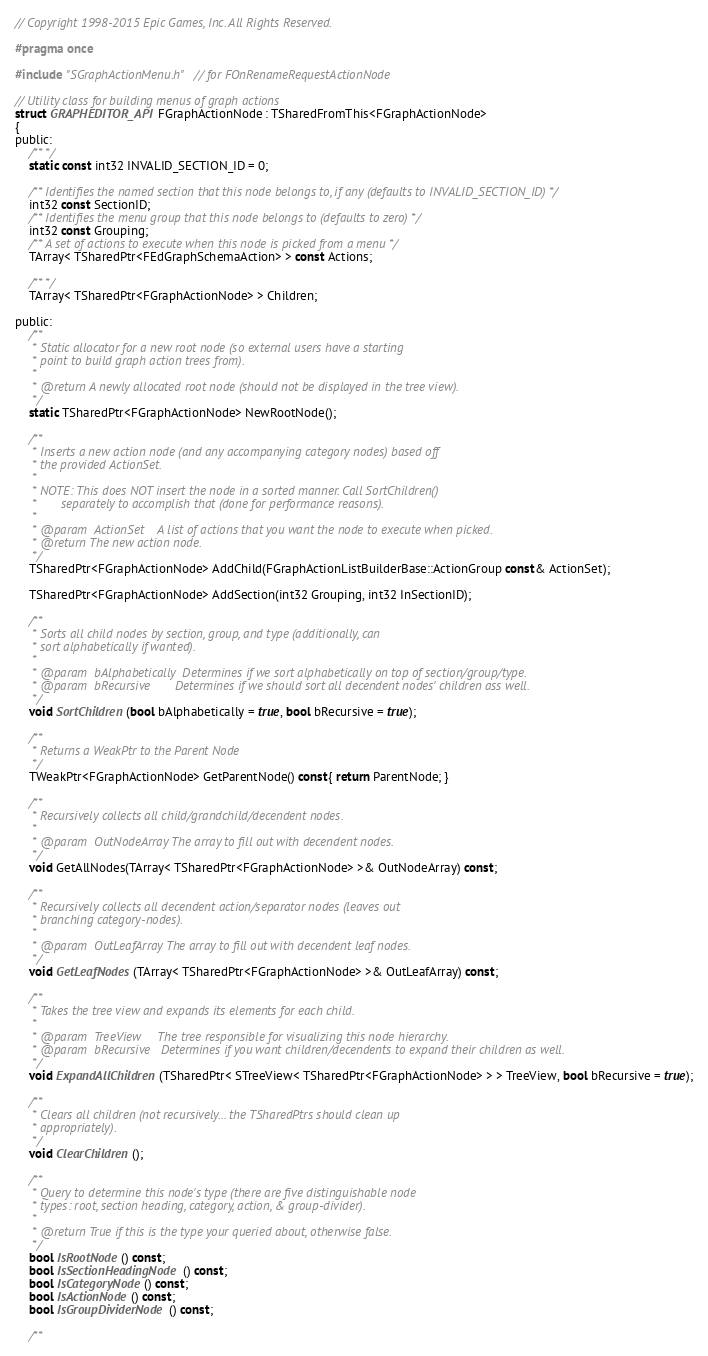Convert code to text. <code><loc_0><loc_0><loc_500><loc_500><_C_>// Copyright 1998-2015 Epic Games, Inc. All Rights Reserved.

#pragma once

#include "SGraphActionMenu.h" // for FOnRenameRequestActionNode

// Utility class for building menus of graph actions
struct GRAPHEDITOR_API FGraphActionNode : TSharedFromThis<FGraphActionNode>
{
public:
	/** */
	static const int32 INVALID_SECTION_ID = 0;

	/** Identifies the named section that this node belongs to, if any (defaults to INVALID_SECTION_ID) */
	int32 const SectionID;
	/** Identifies the menu group that this node belongs to (defaults to zero) */
	int32 const Grouping;
	/** A set of actions to execute when this node is picked from a menu */
	TArray< TSharedPtr<FEdGraphSchemaAction> > const Actions;

	/** */
	TArray< TSharedPtr<FGraphActionNode> > Children;

public:
	/**
	 * Static allocator for a new root node (so external users have a starting
	 * point to build graph action trees from).
	 *
	 * @return A newly allocated root node (should not be displayed in the tree view).
	 */
	static TSharedPtr<FGraphActionNode> NewRootNode();

	/**
	 * Inserts a new action node (and any accompanying category nodes) based off
	 * the provided ActionSet. 
	 *
	 * NOTE: This does NOT insert the node in a sorted manner. Call SortChildren() 
	 *       separately to accomplish that (done for performance reasons).
	 * 
	 * @param  ActionSet	A list of actions that you want the node to execute when picked.
	 * @return The new action node.
	 */
	TSharedPtr<FGraphActionNode> AddChild(FGraphActionListBuilderBase::ActionGroup const& ActionSet);

	TSharedPtr<FGraphActionNode> AddSection(int32 Grouping, int32 InSectionID);

	/**
	 * Sorts all child nodes by section, group, and type (additionally, can
	 * sort alphabetically if wanted).
	 * 
	 * @param  bAlphabetically	Determines if we sort alphabetically on top of section/group/type.
	 * @param  bRecursive		Determines if we should sort all decendent nodes' children ass well.
	 */
	void SortChildren(bool bAlphabetically = true, bool bRecursive = true);

	/**
	 * Returns a WeakPtr to the Parent Node
	 */
	TWeakPtr<FGraphActionNode> GetParentNode() const{ return ParentNode; }

	/**
	 * Recursively collects all child/grandchild/decendent nodes.
	 * 
	 * @param  OutNodeArray	The array to fill out with decendent nodes.
	 */
	void GetAllNodes(TArray< TSharedPtr<FGraphActionNode> >& OutNodeArray) const;

	/**
	 * Recursively collects all decendent action/separator nodes (leaves out 
	 * branching category-nodes).
	 * 
	 * @param  OutLeafArray	The array to fill out with decendent leaf nodes.
	 */
	void GetLeafNodes(TArray< TSharedPtr<FGraphActionNode> >& OutLeafArray) const;

	/**
	 * Takes the tree view and expands its elements for each child.
	 * 
	 * @param  TreeView		The tree responsible for visualizing this node hierarchy.
	 * @param  bRecursive	Determines if you want children/decendents to expand their children as well. 
	 */
	void ExpandAllChildren(TSharedPtr< STreeView< TSharedPtr<FGraphActionNode> > > TreeView, bool bRecursive = true);

	/**
	 * Clears all children (not recursively... the TSharedPtrs should clean up 
	 * appropriately).
	 */
	void ClearChildren();

	/**
	 * Query to determine this node's type (there are five distinguishable node
	 * types: root, section heading, category, action, & group-divider).
	 *
	 * @return True if this is the type your queried about, otherwise false.
	 */
	bool IsRootNode() const;
	bool IsSectionHeadingNode() const;
	bool IsCategoryNode() const;
	bool IsActionNode() const;
	bool IsGroupDividerNode() const;

	/**</code> 